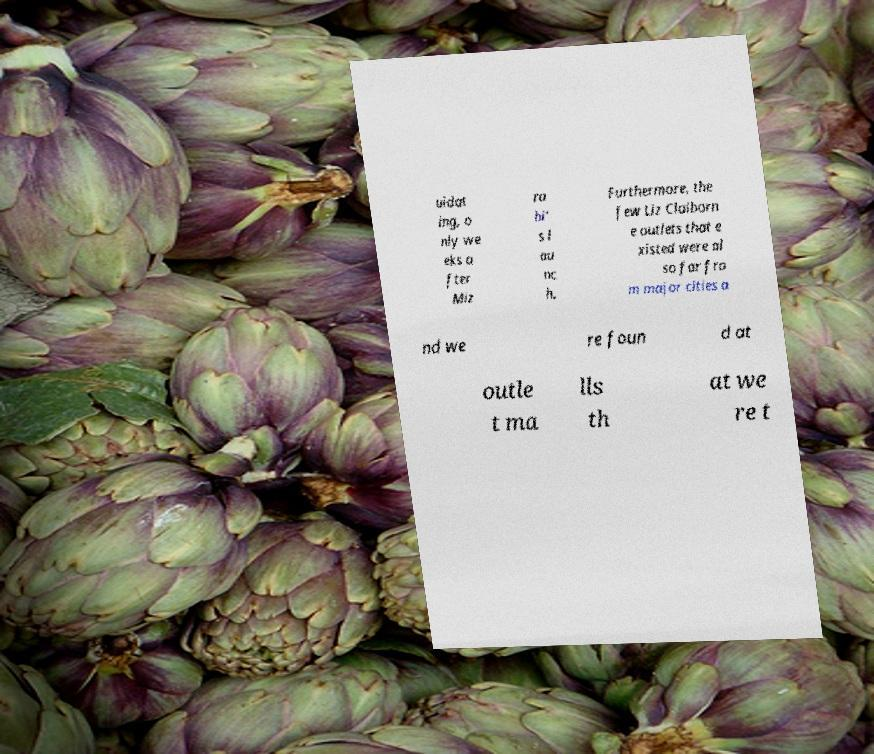Can you accurately transcribe the text from the provided image for me? uidat ing, o nly we eks a fter Miz ra hi' s l au nc h. Furthermore, the few Liz Claiborn e outlets that e xisted were al so far fro m major cities a nd we re foun d at outle t ma lls th at we re t 